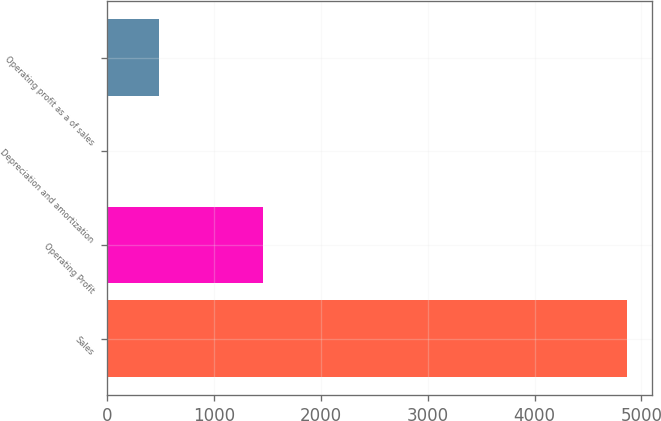Convert chart to OTSL. <chart><loc_0><loc_0><loc_500><loc_500><bar_chart><fcel>Sales<fcel>Operating Profit<fcel>Depreciation and amortization<fcel>Operating profit as a of sales<nl><fcel>4860.8<fcel>1460.13<fcel>2.7<fcel>488.51<nl></chart> 